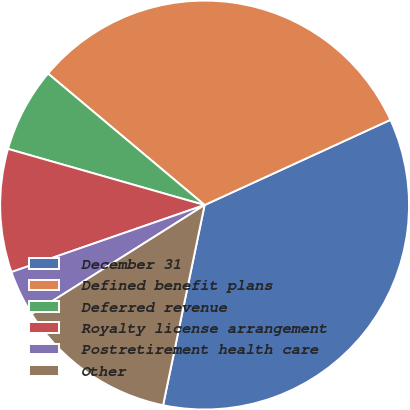Convert chart to OTSL. <chart><loc_0><loc_0><loc_500><loc_500><pie_chart><fcel>December 31<fcel>Defined benefit plans<fcel>Deferred revenue<fcel>Royalty license arrangement<fcel>Postretirement health care<fcel>Other<nl><fcel>35.09%<fcel>32.04%<fcel>6.69%<fcel>9.74%<fcel>3.64%<fcel>12.79%<nl></chart> 